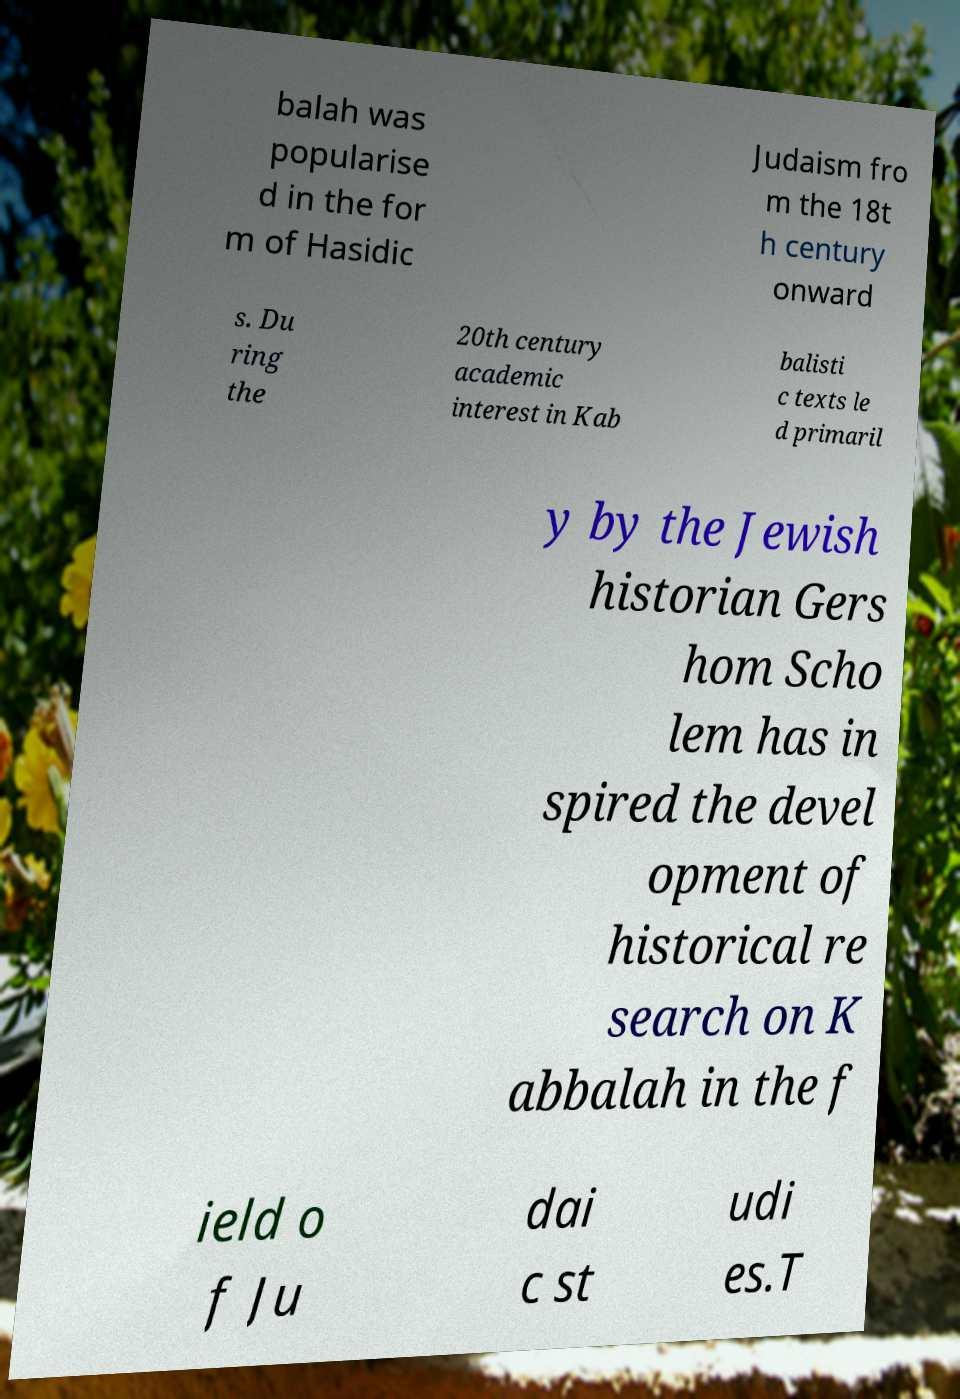I need the written content from this picture converted into text. Can you do that? balah was popularise d in the for m of Hasidic Judaism fro m the 18t h century onward s. Du ring the 20th century academic interest in Kab balisti c texts le d primaril y by the Jewish historian Gers hom Scho lem has in spired the devel opment of historical re search on K abbalah in the f ield o f Ju dai c st udi es.T 